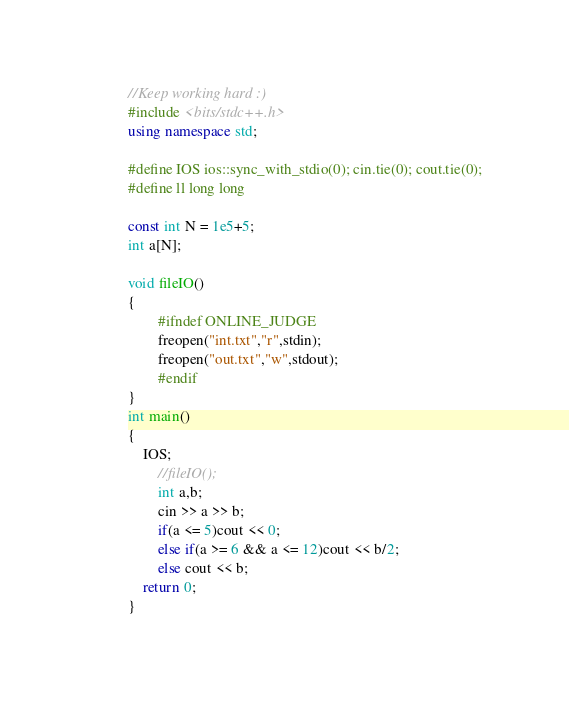Convert code to text. <code><loc_0><loc_0><loc_500><loc_500><_C++_>//Keep working hard :)
#include <bits/stdc++.h>
using namespace std;

#define IOS ios::sync_with_stdio(0); cin.tie(0); cout.tie(0);
#define ll long long

const int N = 1e5+5;
int a[N];

void fileIO()
{
        #ifndef ONLINE_JUDGE
        freopen("int.txt","r",stdin);
        freopen("out.txt","w",stdout);
        #endif
}
int main()
{
	IOS;
        //fileIO();
        int a,b;
        cin >> a >> b;
        if(a <= 5)cout << 0;
        else if(a >= 6 && a <= 12)cout << b/2;
        else cout << b;
	return 0;
}
</code> 